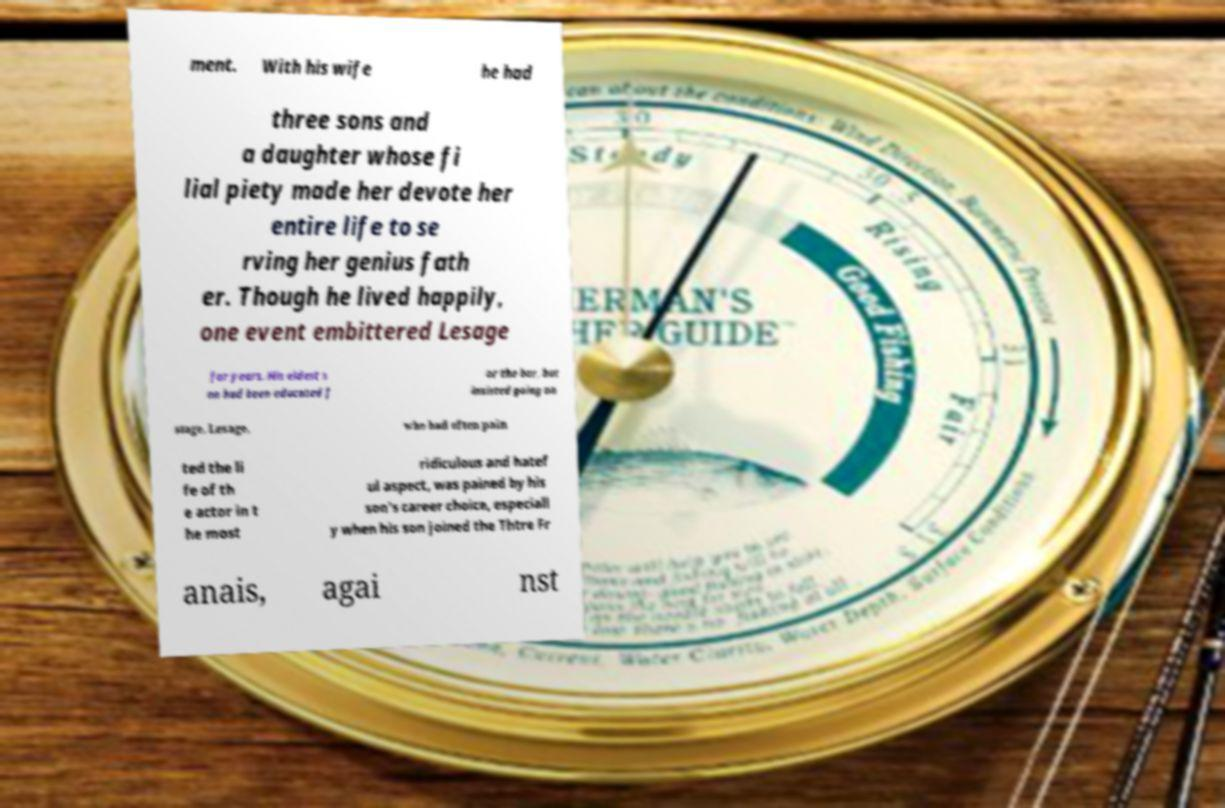Could you assist in decoding the text presented in this image and type it out clearly? ment. With his wife he had three sons and a daughter whose fi lial piety made her devote her entire life to se rving her genius fath er. Though he lived happily, one event embittered Lesage for years. His eldest s on had been educated f or the bar, but insisted going on stage. Lesage, who had often pain ted the li fe of th e actor in t he most ridiculous and hatef ul aspect, was pained by his son's career choice, especiall y when his son joined the Thtre Fr anais, agai nst 